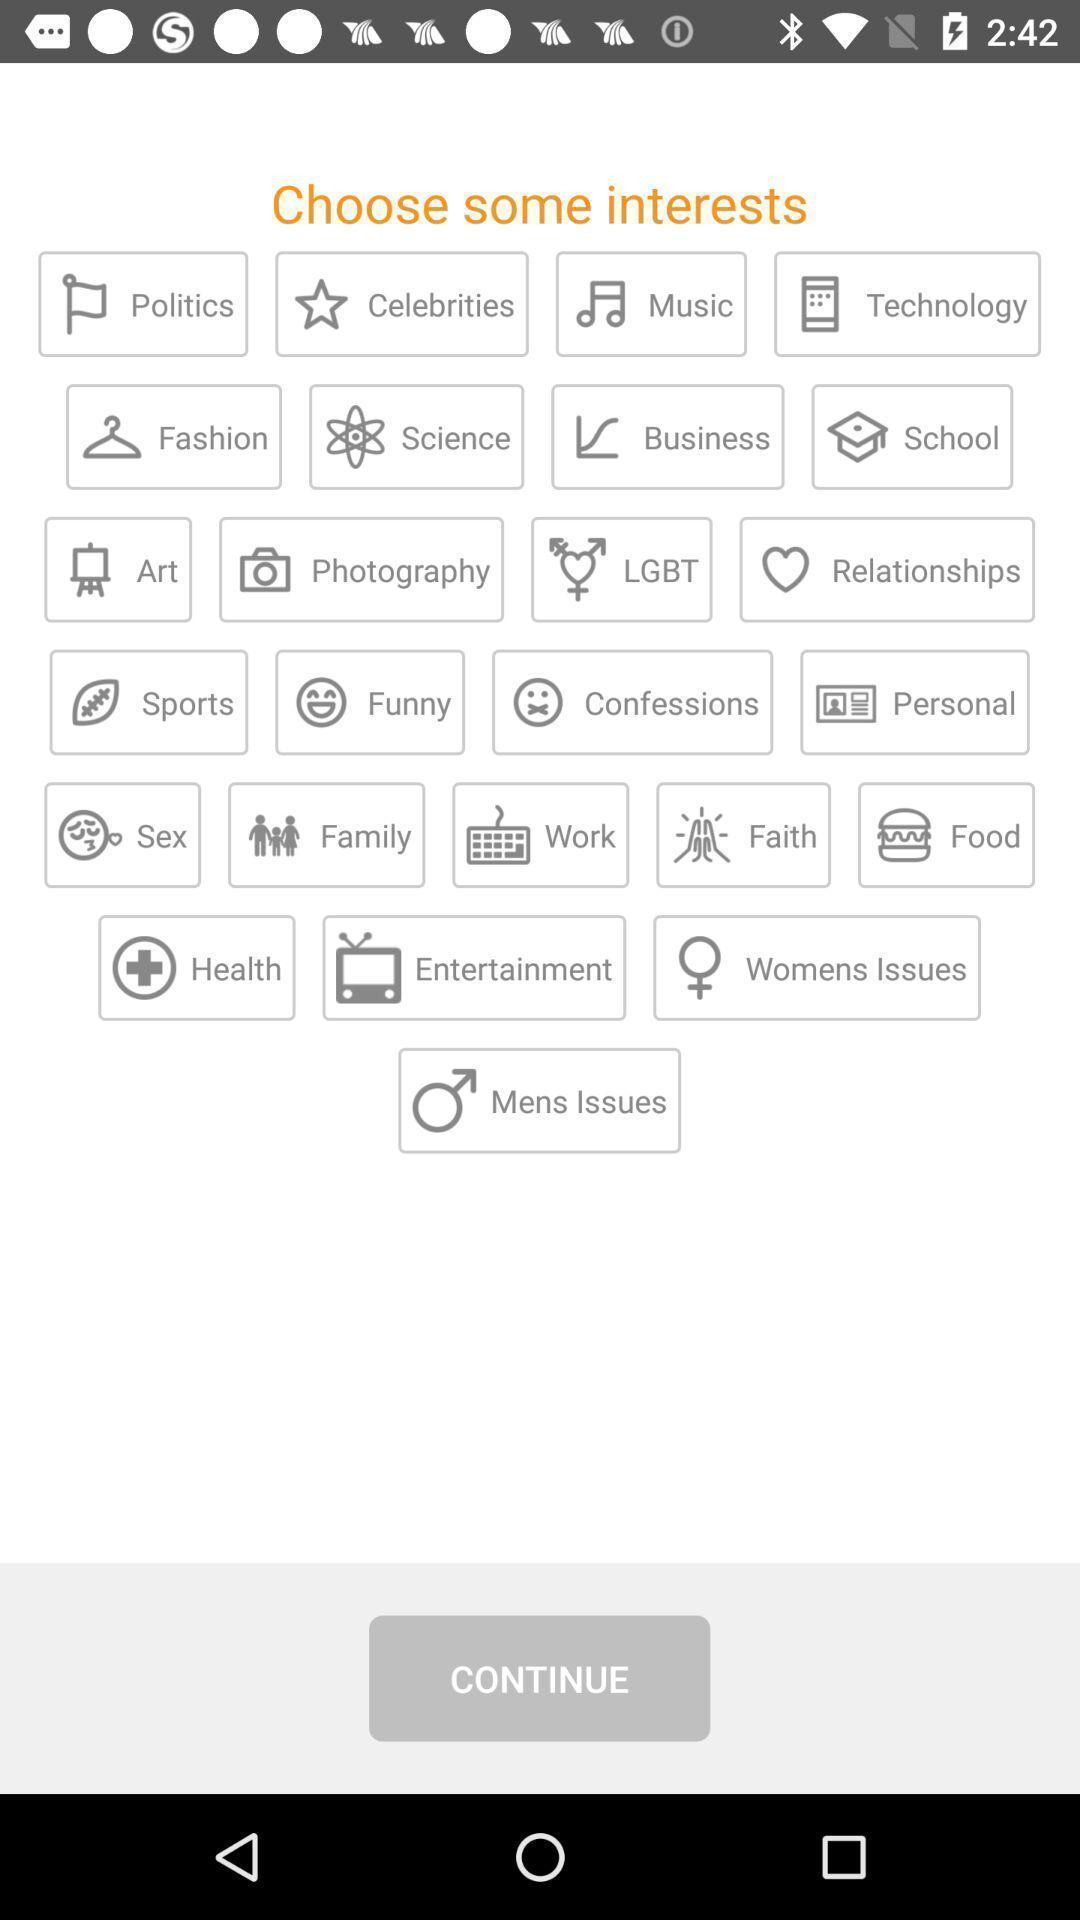Give me a narrative description of this picture. Screen showing list of various categories. 